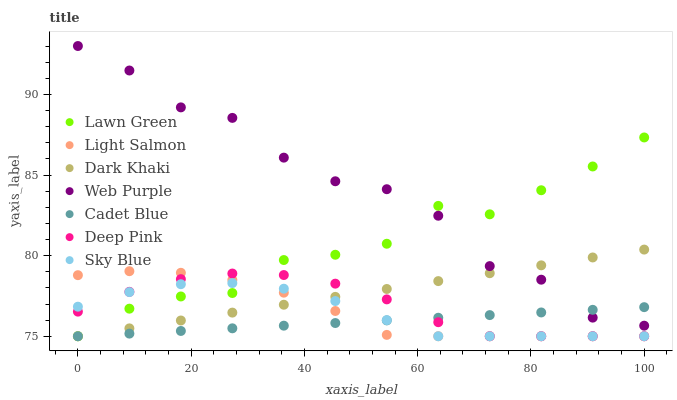Does Cadet Blue have the minimum area under the curve?
Answer yes or no. Yes. Does Web Purple have the maximum area under the curve?
Answer yes or no. Yes. Does Light Salmon have the minimum area under the curve?
Answer yes or no. No. Does Light Salmon have the maximum area under the curve?
Answer yes or no. No. Is Cadet Blue the smoothest?
Answer yes or no. Yes. Is Web Purple the roughest?
Answer yes or no. Yes. Is Light Salmon the smoothest?
Answer yes or no. No. Is Light Salmon the roughest?
Answer yes or no. No. Does Lawn Green have the lowest value?
Answer yes or no. Yes. Does Web Purple have the lowest value?
Answer yes or no. No. Does Web Purple have the highest value?
Answer yes or no. Yes. Does Light Salmon have the highest value?
Answer yes or no. No. Is Sky Blue less than Web Purple?
Answer yes or no. Yes. Is Web Purple greater than Deep Pink?
Answer yes or no. Yes. Does Cadet Blue intersect Lawn Green?
Answer yes or no. Yes. Is Cadet Blue less than Lawn Green?
Answer yes or no. No. Is Cadet Blue greater than Lawn Green?
Answer yes or no. No. Does Sky Blue intersect Web Purple?
Answer yes or no. No. 